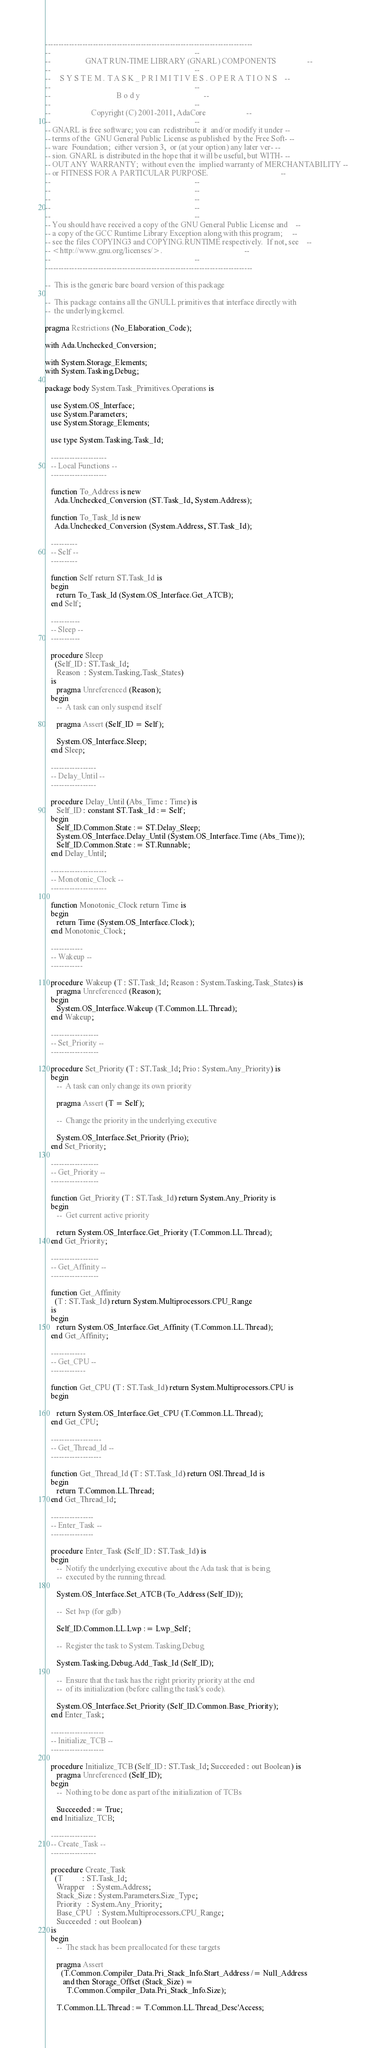<code> <loc_0><loc_0><loc_500><loc_500><_Ada_>------------------------------------------------------------------------------
--                                                                          --
--                  GNAT RUN-TIME LIBRARY (GNARL) COMPONENTS                --
--                                                                          --
--     S Y S T E M . T A S K _ P R I M I T I V E S . O P E R A T I O N S    --
--                                                                          --
--                                  B o d y                                 --
--                                                                          --
--                     Copyright (C) 2001-2011, AdaCore                     --
--                                                                          --
-- GNARL is free software; you can  redistribute it  and/or modify it under --
-- terms of the  GNU General Public License as published  by the Free Soft- --
-- ware  Foundation;  either version 3,  or (at your option) any later ver- --
-- sion. GNARL is distributed in the hope that it will be useful, but WITH- --
-- OUT ANY WARRANTY;  without even the  implied warranty of MERCHANTABILITY --
-- or FITNESS FOR A PARTICULAR PURPOSE.                                     --
--                                                                          --
--                                                                          --
--                                                                          --
--                                                                          --
--                                                                          --
-- You should have received a copy of the GNU General Public License and    --
-- a copy of the GCC Runtime Library Exception along with this program;     --
-- see the files COPYING3 and COPYING.RUNTIME respectively.  If not, see    --
-- <http://www.gnu.org/licenses/>.                                          --
--                                                                          --
------------------------------------------------------------------------------

--  This is the generic bare board version of this package

--  This package contains all the GNULL primitives that interface directly with
--  the underlying kernel.

pragma Restrictions (No_Elaboration_Code);

with Ada.Unchecked_Conversion;

with System.Storage_Elements;
with System.Tasking.Debug;

package body System.Task_Primitives.Operations is

   use System.OS_Interface;
   use System.Parameters;
   use System.Storage_Elements;

   use type System.Tasking.Task_Id;

   ---------------------
   -- Local Functions --
   ---------------------

   function To_Address is new
     Ada.Unchecked_Conversion (ST.Task_Id, System.Address);

   function To_Task_Id is new
     Ada.Unchecked_Conversion (System.Address, ST.Task_Id);

   ----------
   -- Self --
   ----------

   function Self return ST.Task_Id is
   begin
      return To_Task_Id (System.OS_Interface.Get_ATCB);
   end Self;

   -----------
   -- Sleep --
   -----------

   procedure Sleep
     (Self_ID : ST.Task_Id;
      Reason  : System.Tasking.Task_States)
   is
      pragma Unreferenced (Reason);
   begin
      --  A task can only suspend itself

      pragma Assert (Self_ID = Self);

      System.OS_Interface.Sleep;
   end Sleep;

   -----------------
   -- Delay_Until --
   -----------------

   procedure Delay_Until (Abs_Time : Time) is
      Self_ID : constant ST.Task_Id := Self;
   begin
      Self_ID.Common.State := ST.Delay_Sleep;
      System.OS_Interface.Delay_Until (System.OS_Interface.Time (Abs_Time));
      Self_ID.Common.State := ST.Runnable;
   end Delay_Until;

   ---------------------
   -- Monotonic_Clock --
   ---------------------

   function Monotonic_Clock return Time is
   begin
      return Time (System.OS_Interface.Clock);
   end Monotonic_Clock;

   ------------
   -- Wakeup --
   ------------

   procedure Wakeup (T : ST.Task_Id; Reason : System.Tasking.Task_States) is
      pragma Unreferenced (Reason);
   begin
      System.OS_Interface.Wakeup (T.Common.LL.Thread);
   end Wakeup;

   ------------------
   -- Set_Priority --
   ------------------

   procedure Set_Priority (T : ST.Task_Id; Prio : System.Any_Priority) is
   begin
      --  A task can only change its own priority

      pragma Assert (T = Self);

      --  Change the priority in the underlying executive

      System.OS_Interface.Set_Priority (Prio);
   end Set_Priority;

   ------------------
   -- Get_Priority --
   ------------------

   function Get_Priority (T : ST.Task_Id) return System.Any_Priority is
   begin
      --  Get current active priority

      return System.OS_Interface.Get_Priority (T.Common.LL.Thread);
   end Get_Priority;

   ------------------
   -- Get_Affinity --
   ------------------

   function Get_Affinity
     (T : ST.Task_Id) return System.Multiprocessors.CPU_Range
   is
   begin
      return System.OS_Interface.Get_Affinity (T.Common.LL.Thread);
   end Get_Affinity;

   -------------
   -- Get_CPU --
   -------------

   function Get_CPU (T : ST.Task_Id) return System.Multiprocessors.CPU is
   begin

      return System.OS_Interface.Get_CPU (T.Common.LL.Thread);
   end Get_CPU;

   -------------------
   -- Get_Thread_Id --
   -------------------

   function Get_Thread_Id (T : ST.Task_Id) return OSI.Thread_Id is
   begin
      return T.Common.LL.Thread;
   end Get_Thread_Id;

   ----------------
   -- Enter_Task --
   ----------------

   procedure Enter_Task (Self_ID : ST.Task_Id) is
   begin
      --  Notify the underlying executive about the Ada task that is being
      --  executed by the running thread.

      System.OS_Interface.Set_ATCB (To_Address (Self_ID));

      --  Set lwp (for gdb)

      Self_ID.Common.LL.Lwp := Lwp_Self;

      --  Register the task to System.Tasking.Debug

      System.Tasking.Debug.Add_Task_Id (Self_ID);

      --  Ensure that the task has the right priority priority at the end
      --  of its initialization (before calling the task's code).

      System.OS_Interface.Set_Priority (Self_ID.Common.Base_Priority);
   end Enter_Task;

   --------------------
   -- Initialize_TCB --
   --------------------

   procedure Initialize_TCB (Self_ID : ST.Task_Id; Succeeded : out Boolean) is
      pragma Unreferenced (Self_ID);
   begin
      --  Nothing to be done as part of the initialization of TCBs

      Succeeded := True;
   end Initialize_TCB;

   -----------------
   -- Create_Task --
   -----------------

   procedure Create_Task
     (T          : ST.Task_Id;
      Wrapper    : System.Address;
      Stack_Size : System.Parameters.Size_Type;
      Priority   : System.Any_Priority;
      Base_CPU   : System.Multiprocessors.CPU_Range;
      Succeeded  : out Boolean)
   is
   begin
      --  The stack has been preallocated for these targets

      pragma Assert
        (T.Common.Compiler_Data.Pri_Stack_Info.Start_Address /= Null_Address
         and then Storage_Offset (Stack_Size) =
           T.Common.Compiler_Data.Pri_Stack_Info.Size);

      T.Common.LL.Thread := T.Common.LL.Thread_Desc'Access;
</code> 